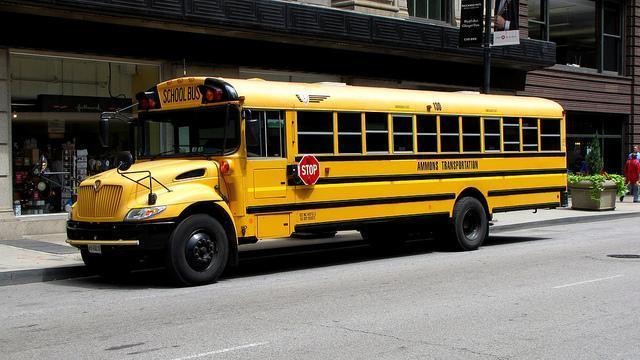How many buses are in the photo?
Give a very brief answer. 1. 